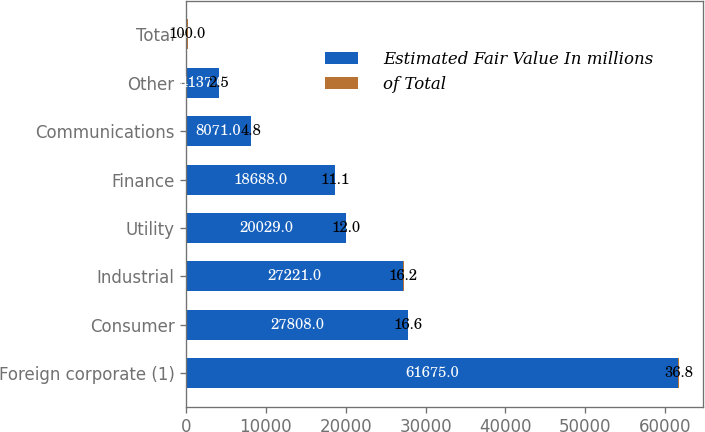Convert chart. <chart><loc_0><loc_0><loc_500><loc_500><stacked_bar_chart><ecel><fcel>Foreign corporate (1)<fcel>Consumer<fcel>Industrial<fcel>Utility<fcel>Finance<fcel>Communications<fcel>Other<fcel>Total<nl><fcel>Estimated Fair Value In millions<fcel>61675<fcel>27808<fcel>27221<fcel>20029<fcel>18688<fcel>8071<fcel>4137<fcel>100<nl><fcel>of Total<fcel>36.8<fcel>16.6<fcel>16.2<fcel>12<fcel>11.1<fcel>4.8<fcel>2.5<fcel>100<nl></chart> 